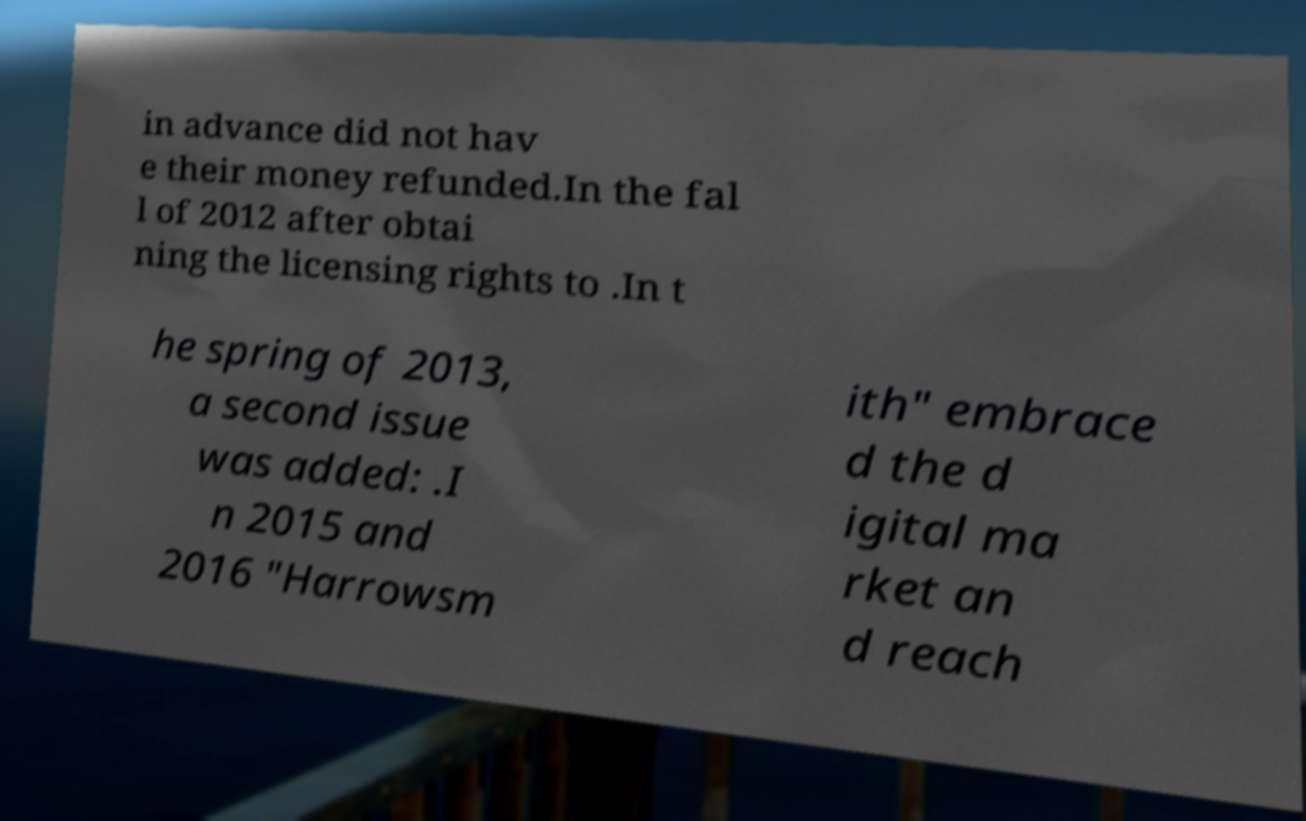There's text embedded in this image that I need extracted. Can you transcribe it verbatim? in advance did not hav e their money refunded.In the fal l of 2012 after obtai ning the licensing rights to .In t he spring of 2013, a second issue was added: .I n 2015 and 2016 "Harrowsm ith" embrace d the d igital ma rket an d reach 